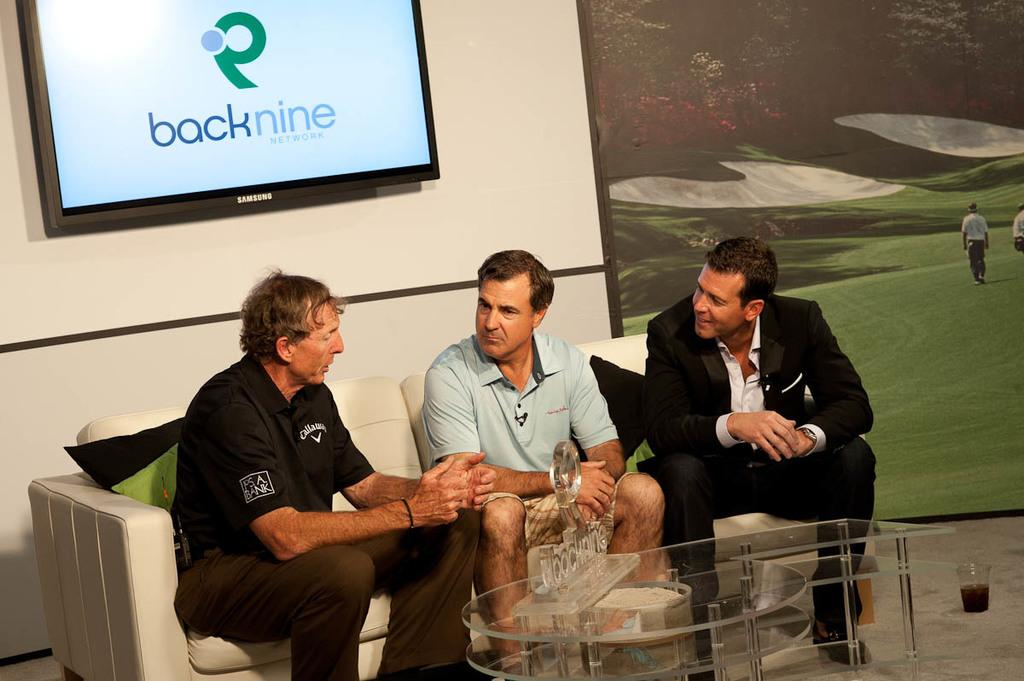How many people are sitting on the sofa in the image? There are three people sitting on the sofa in the image. What can be seen on the wall in the image? There is a photo and a television on the wall in the image. What type of table is present in the image? There is a glass table in the image. What is on the table in the image? There is a glass on the table in the image. Is there a volcano erupting in the background of the image? There is no volcano present in the image. What type of key is being used to unlock the television in the image? There is no key or locking mechanism present on the television in the image. 